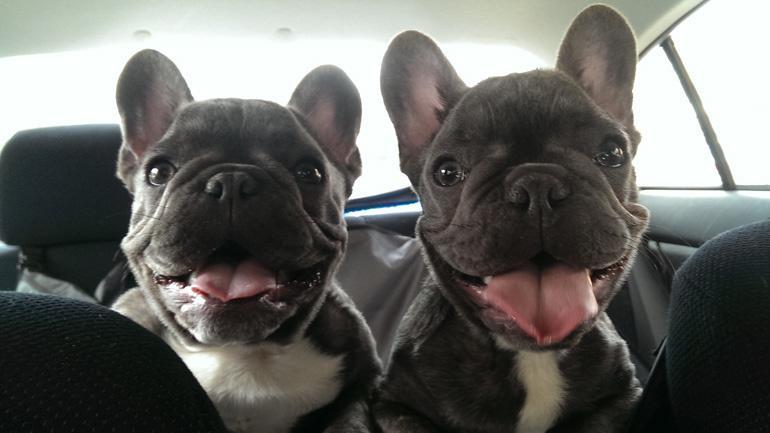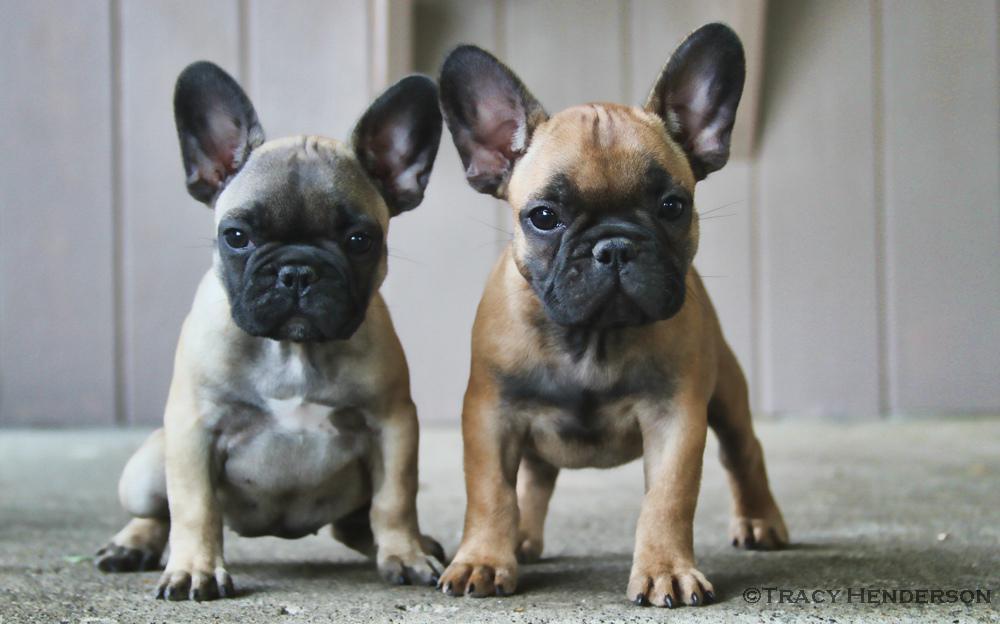The first image is the image on the left, the second image is the image on the right. Examine the images to the left and right. Is the description "Each image contains a pair of big-eared dogs, and the pair on the left stand on all fours." accurate? Answer yes or no. No. 